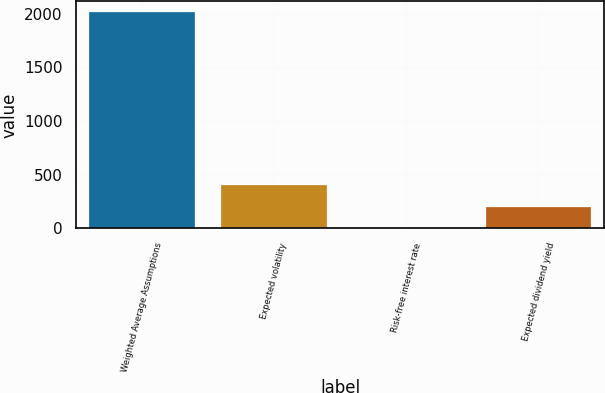Convert chart to OTSL. <chart><loc_0><loc_0><loc_500><loc_500><bar_chart><fcel>Weighted Average Assumptions<fcel>Expected volatility<fcel>Risk-free interest rate<fcel>Expected dividend yield<nl><fcel>2015<fcel>404.36<fcel>1.7<fcel>203.03<nl></chart> 